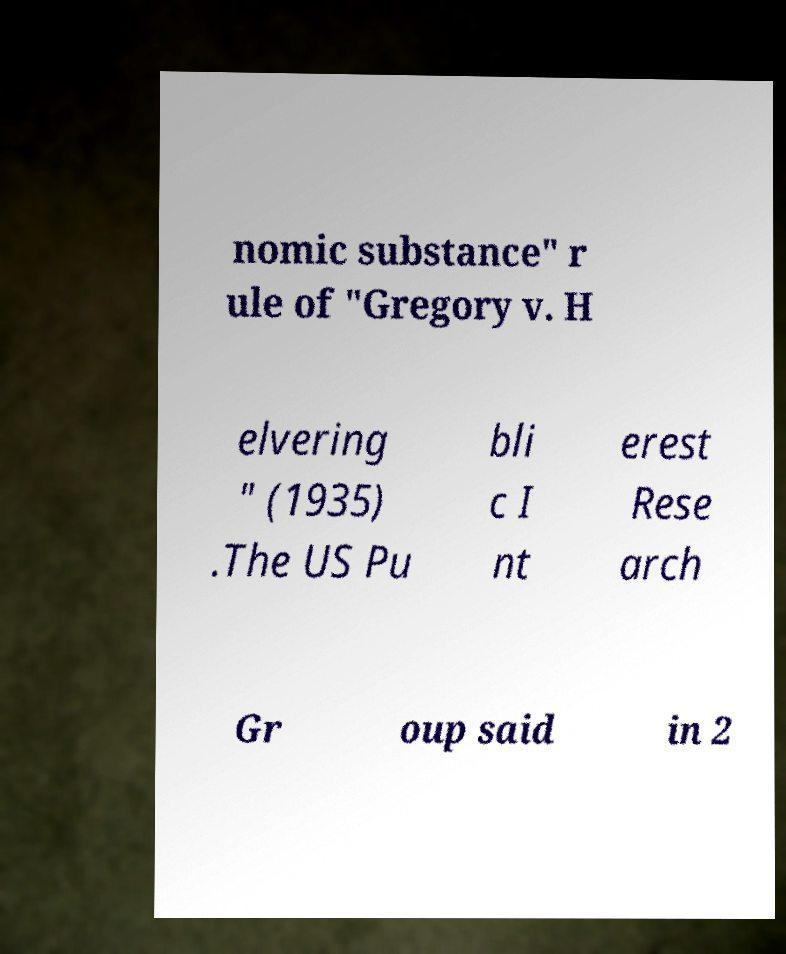Please identify and transcribe the text found in this image. nomic substance" r ule of "Gregory v. H elvering " (1935) .The US Pu bli c I nt erest Rese arch Gr oup said in 2 